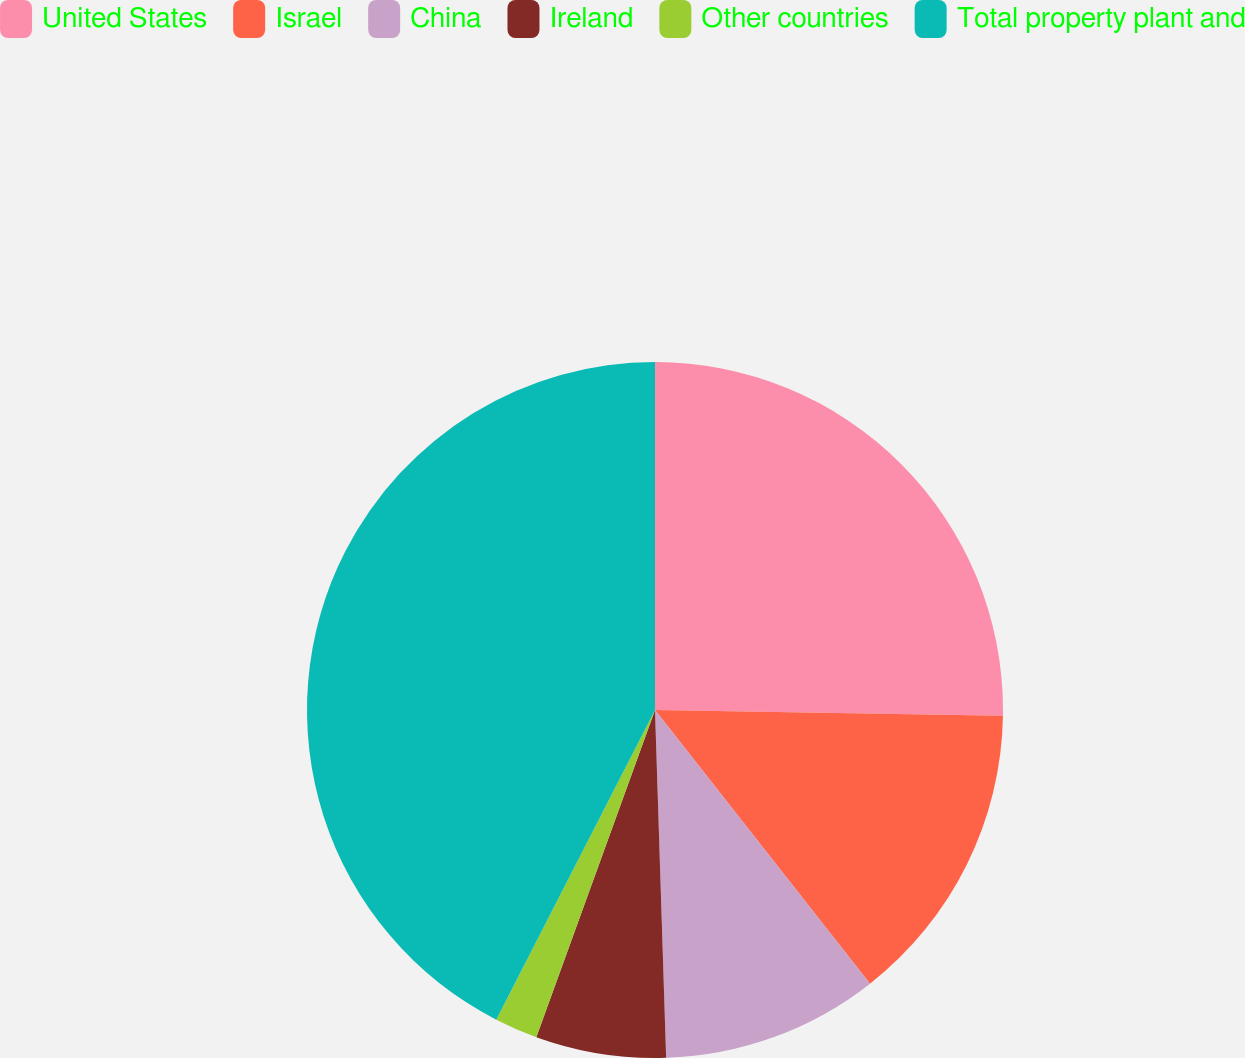Convert chart to OTSL. <chart><loc_0><loc_0><loc_500><loc_500><pie_chart><fcel>United States<fcel>Israel<fcel>China<fcel>Ireland<fcel>Other countries<fcel>Total property plant and<nl><fcel>25.26%<fcel>14.14%<fcel>10.09%<fcel>6.05%<fcel>2.0%<fcel>42.46%<nl></chart> 